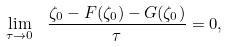Convert formula to latex. <formula><loc_0><loc_0><loc_500><loc_500>\lim _ { \tau \to 0 } \ \frac { \zeta _ { 0 } - F ( \zeta _ { 0 } ) - G ( \zeta _ { 0 } ) } { \tau } = 0 ,</formula> 